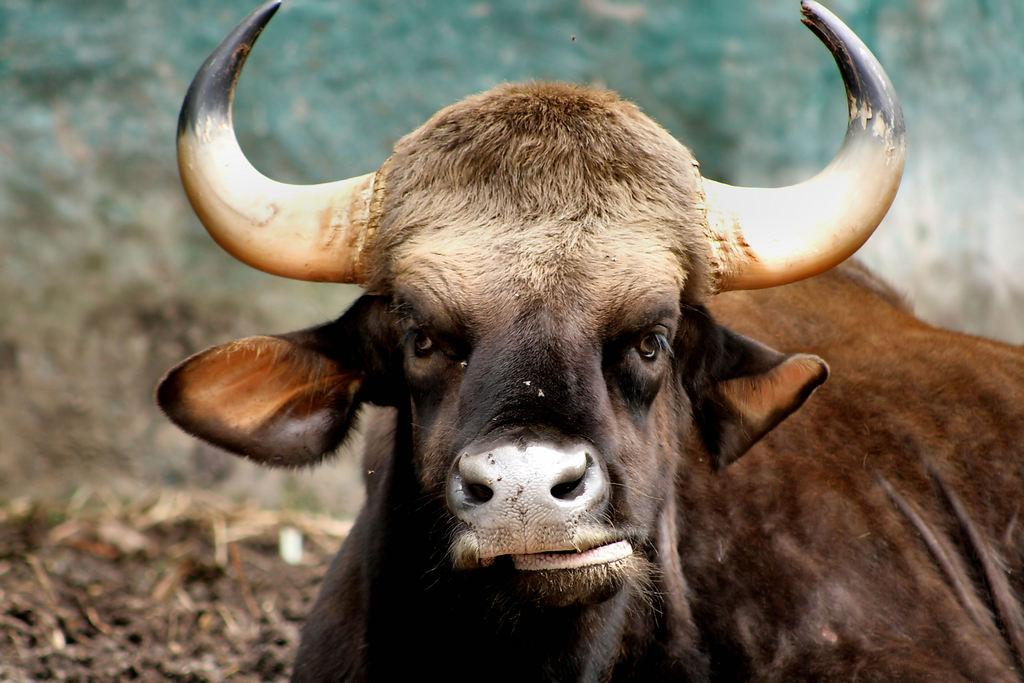What animal is the main subject of the image? There is a buffalo in the image. Can you describe the color of the buffalo? The buffalo is black and brown in color. What can be observed about the background of the image? The background of the image is blurred. How many teeth can be seen in the boat in the image? There is no boat present in the image, and therefore no teeth can be seen in a boat. 